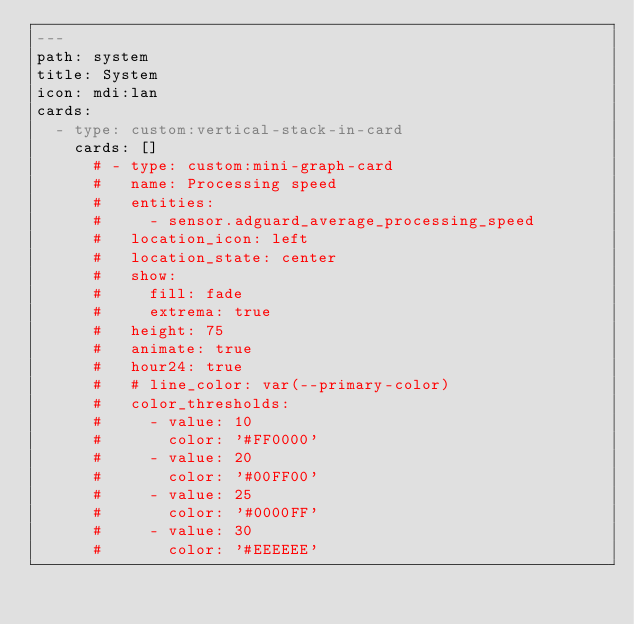Convert code to text. <code><loc_0><loc_0><loc_500><loc_500><_YAML_>---
path: system
title: System
icon: mdi:lan
cards:
  - type: custom:vertical-stack-in-card
    cards: []
      # - type: custom:mini-graph-card
      #   name: Processing speed
      #   entities:
      #     - sensor.adguard_average_processing_speed
      #   location_icon: left
      #   location_state: center
      #   show:
      #     fill: fade
      #     extrema: true
      #   height: 75
      #   animate: true
      #   hour24: true
      #   # line_color: var(--primary-color)
      #   color_thresholds:
      #     - value: 10
      #       color: '#FF0000'
      #     - value: 20
      #       color: '#00FF00'
      #     - value: 25
      #       color: '#0000FF'
      #     - value: 30
      #       color: '#EEEEEE'

</code> 